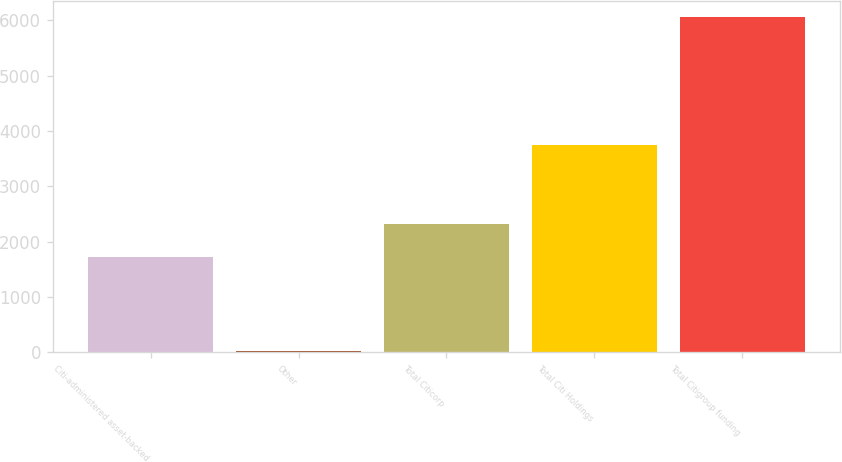Convert chart to OTSL. <chart><loc_0><loc_0><loc_500><loc_500><bar_chart><fcel>Citi-administered asset-backed<fcel>Other<fcel>Total Citicorp<fcel>Total Citi Holdings<fcel>Total Citigroup funding<nl><fcel>1718<fcel>23<fcel>2321.3<fcel>3748<fcel>6056<nl></chart> 